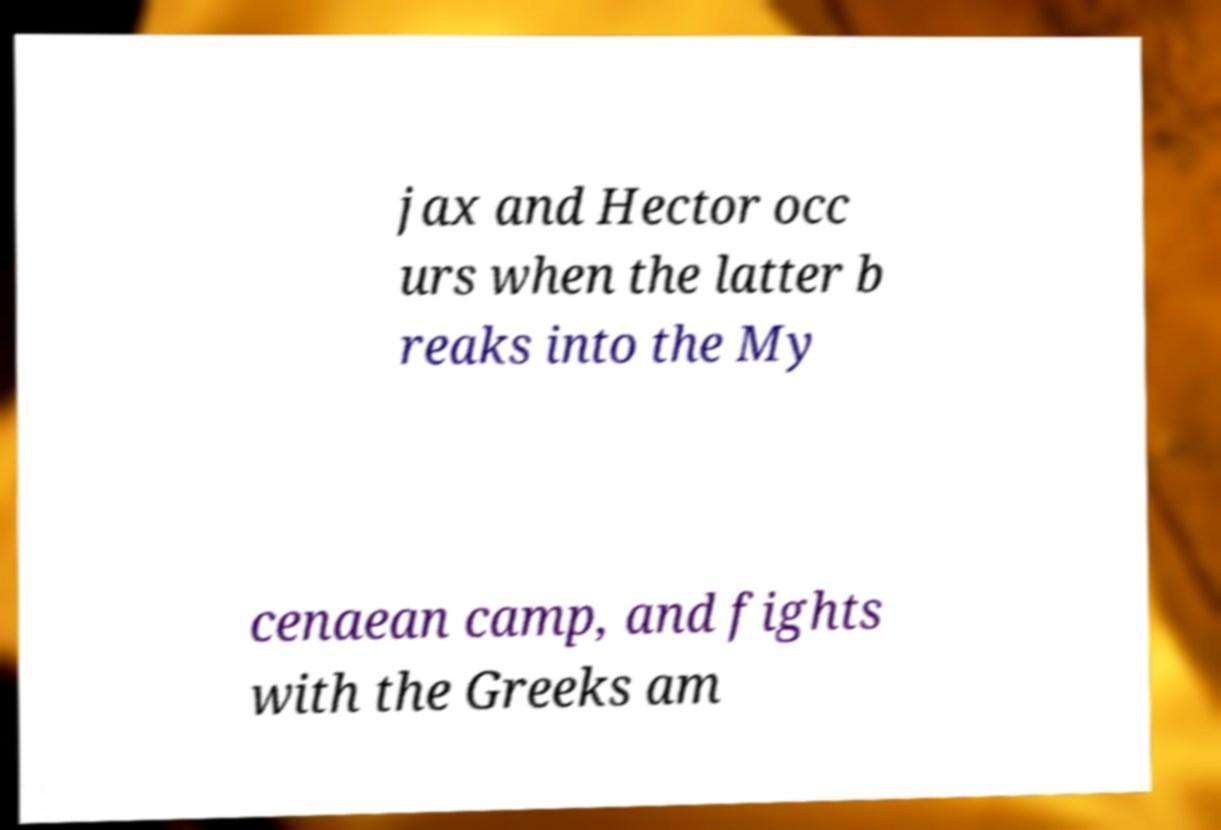Can you read and provide the text displayed in the image?This photo seems to have some interesting text. Can you extract and type it out for me? jax and Hector occ urs when the latter b reaks into the My cenaean camp, and fights with the Greeks am 